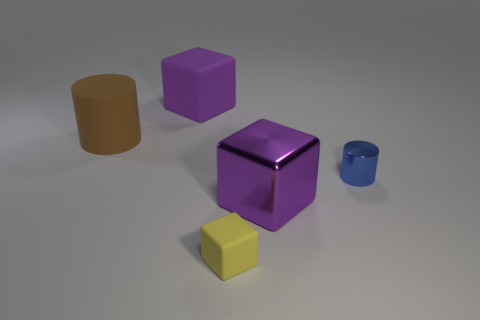Add 2 blue metallic objects. How many objects exist? 7 Subtract all cylinders. How many objects are left? 3 Subtract all shiny cylinders. Subtract all tiny purple metallic balls. How many objects are left? 4 Add 4 small yellow blocks. How many small yellow blocks are left? 5 Add 5 cylinders. How many cylinders exist? 7 Subtract 2 purple blocks. How many objects are left? 3 